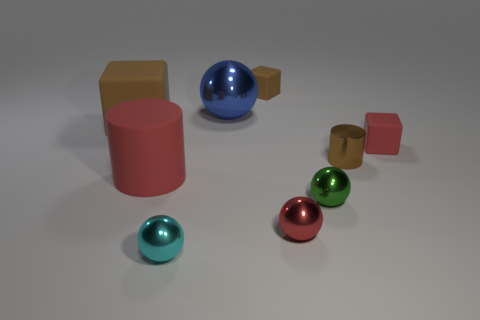Subtract all large brown matte cubes. How many cubes are left? 2 Subtract all red spheres. How many spheres are left? 3 Subtract 3 balls. How many balls are left? 1 Subtract all red cubes. How many cyan spheres are left? 1 Subtract all spheres. How many objects are left? 5 Subtract all yellow cubes. Subtract all gray balls. How many cubes are left? 3 Subtract all cylinders. Subtract all tiny brown blocks. How many objects are left? 6 Add 6 small green balls. How many small green balls are left? 7 Add 1 tiny blocks. How many tiny blocks exist? 3 Subtract 1 red cubes. How many objects are left? 8 